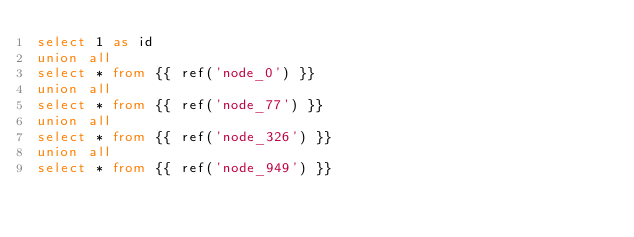Convert code to text. <code><loc_0><loc_0><loc_500><loc_500><_SQL_>select 1 as id
union all
select * from {{ ref('node_0') }}
union all
select * from {{ ref('node_77') }}
union all
select * from {{ ref('node_326') }}
union all
select * from {{ ref('node_949') }}</code> 